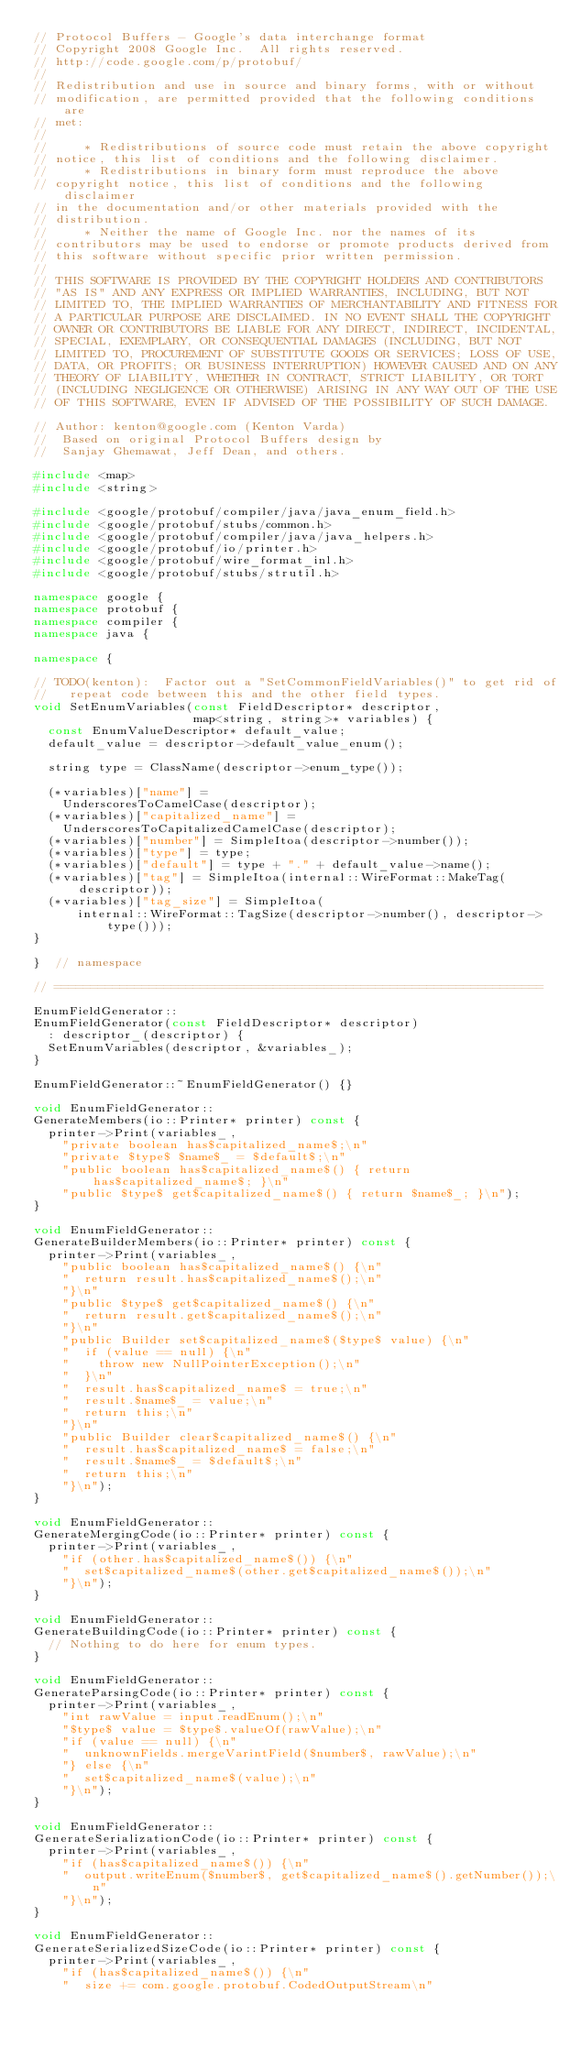Convert code to text. <code><loc_0><loc_0><loc_500><loc_500><_C++_>// Protocol Buffers - Google's data interchange format
// Copyright 2008 Google Inc.  All rights reserved.
// http://code.google.com/p/protobuf/
//
// Redistribution and use in source and binary forms, with or without
// modification, are permitted provided that the following conditions are
// met:
//
//     * Redistributions of source code must retain the above copyright
// notice, this list of conditions and the following disclaimer.
//     * Redistributions in binary form must reproduce the above
// copyright notice, this list of conditions and the following disclaimer
// in the documentation and/or other materials provided with the
// distribution.
//     * Neither the name of Google Inc. nor the names of its
// contributors may be used to endorse or promote products derived from
// this software without specific prior written permission.
//
// THIS SOFTWARE IS PROVIDED BY THE COPYRIGHT HOLDERS AND CONTRIBUTORS
// "AS IS" AND ANY EXPRESS OR IMPLIED WARRANTIES, INCLUDING, BUT NOT
// LIMITED TO, THE IMPLIED WARRANTIES OF MERCHANTABILITY AND FITNESS FOR
// A PARTICULAR PURPOSE ARE DISCLAIMED. IN NO EVENT SHALL THE COPYRIGHT
// OWNER OR CONTRIBUTORS BE LIABLE FOR ANY DIRECT, INDIRECT, INCIDENTAL,
// SPECIAL, EXEMPLARY, OR CONSEQUENTIAL DAMAGES (INCLUDING, BUT NOT
// LIMITED TO, PROCUREMENT OF SUBSTITUTE GOODS OR SERVICES; LOSS OF USE,
// DATA, OR PROFITS; OR BUSINESS INTERRUPTION) HOWEVER CAUSED AND ON ANY
// THEORY OF LIABILITY, WHETHER IN CONTRACT, STRICT LIABILITY, OR TORT
// (INCLUDING NEGLIGENCE OR OTHERWISE) ARISING IN ANY WAY OUT OF THE USE
// OF THIS SOFTWARE, EVEN IF ADVISED OF THE POSSIBILITY OF SUCH DAMAGE.

// Author: kenton@google.com (Kenton Varda)
//  Based on original Protocol Buffers design by
//  Sanjay Ghemawat, Jeff Dean, and others.

#include <map>
#include <string>

#include <google/protobuf/compiler/java/java_enum_field.h>
#include <google/protobuf/stubs/common.h>
#include <google/protobuf/compiler/java/java_helpers.h>
#include <google/protobuf/io/printer.h>
#include <google/protobuf/wire_format_inl.h>
#include <google/protobuf/stubs/strutil.h>

namespace google {
namespace protobuf {
namespace compiler {
namespace java {

namespace {

// TODO(kenton):  Factor out a "SetCommonFieldVariables()" to get rid of
//   repeat code between this and the other field types.
void SetEnumVariables(const FieldDescriptor* descriptor,
                      map<string, string>* variables) {
  const EnumValueDescriptor* default_value;
  default_value = descriptor->default_value_enum();

  string type = ClassName(descriptor->enum_type());

  (*variables)["name"] =
    UnderscoresToCamelCase(descriptor);
  (*variables)["capitalized_name"] =
    UnderscoresToCapitalizedCamelCase(descriptor);
  (*variables)["number"] = SimpleItoa(descriptor->number());
  (*variables)["type"] = type;
  (*variables)["default"] = type + "." + default_value->name();
  (*variables)["tag"] = SimpleItoa(internal::WireFormat::MakeTag(descriptor));
  (*variables)["tag_size"] = SimpleItoa(
      internal::WireFormat::TagSize(descriptor->number(), descriptor->type()));
}

}  // namespace

// ===================================================================

EnumFieldGenerator::
EnumFieldGenerator(const FieldDescriptor* descriptor)
  : descriptor_(descriptor) {
  SetEnumVariables(descriptor, &variables_);
}

EnumFieldGenerator::~EnumFieldGenerator() {}

void EnumFieldGenerator::
GenerateMembers(io::Printer* printer) const {
  printer->Print(variables_,
    "private boolean has$capitalized_name$;\n"
    "private $type$ $name$_ = $default$;\n"
    "public boolean has$capitalized_name$() { return has$capitalized_name$; }\n"
    "public $type$ get$capitalized_name$() { return $name$_; }\n");
}

void EnumFieldGenerator::
GenerateBuilderMembers(io::Printer* printer) const {
  printer->Print(variables_,
    "public boolean has$capitalized_name$() {\n"
    "  return result.has$capitalized_name$();\n"
    "}\n"
    "public $type$ get$capitalized_name$() {\n"
    "  return result.get$capitalized_name$();\n"
    "}\n"
    "public Builder set$capitalized_name$($type$ value) {\n"
    "  if (value == null) {\n"
    "    throw new NullPointerException();\n"
    "  }\n"
    "  result.has$capitalized_name$ = true;\n"
    "  result.$name$_ = value;\n"
    "  return this;\n"
    "}\n"
    "public Builder clear$capitalized_name$() {\n"
    "  result.has$capitalized_name$ = false;\n"
    "  result.$name$_ = $default$;\n"
    "  return this;\n"
    "}\n");
}

void EnumFieldGenerator::
GenerateMergingCode(io::Printer* printer) const {
  printer->Print(variables_,
    "if (other.has$capitalized_name$()) {\n"
    "  set$capitalized_name$(other.get$capitalized_name$());\n"
    "}\n");
}

void EnumFieldGenerator::
GenerateBuildingCode(io::Printer* printer) const {
  // Nothing to do here for enum types.
}

void EnumFieldGenerator::
GenerateParsingCode(io::Printer* printer) const {
  printer->Print(variables_,
    "int rawValue = input.readEnum();\n"
    "$type$ value = $type$.valueOf(rawValue);\n"
    "if (value == null) {\n"
    "  unknownFields.mergeVarintField($number$, rawValue);\n"
    "} else {\n"
    "  set$capitalized_name$(value);\n"
    "}\n");
}

void EnumFieldGenerator::
GenerateSerializationCode(io::Printer* printer) const {
  printer->Print(variables_,
    "if (has$capitalized_name$()) {\n"
    "  output.writeEnum($number$, get$capitalized_name$().getNumber());\n"
    "}\n");
}

void EnumFieldGenerator::
GenerateSerializedSizeCode(io::Printer* printer) const {
  printer->Print(variables_,
    "if (has$capitalized_name$()) {\n"
    "  size += com.google.protobuf.CodedOutputStream\n"</code> 